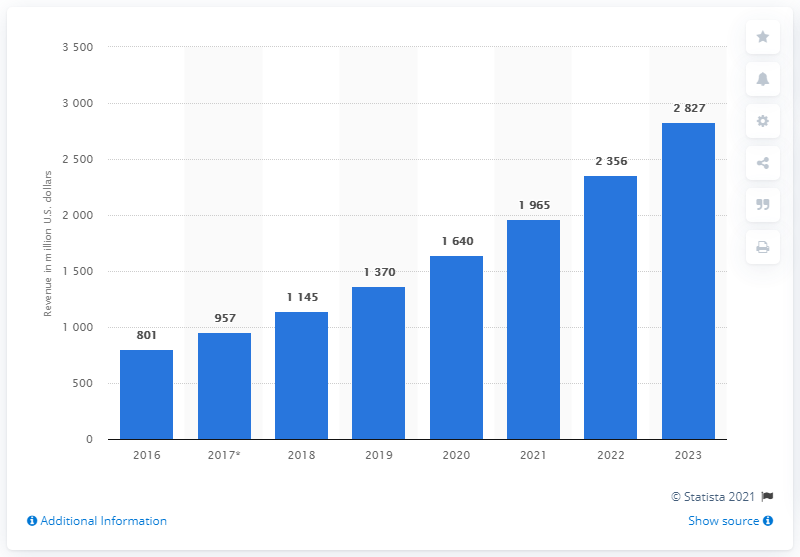Draw attention to some important aspects in this diagram. The projected revenue for the cancer and tumor profiling market in China by 2023 is expected to be approximately 2,827. 